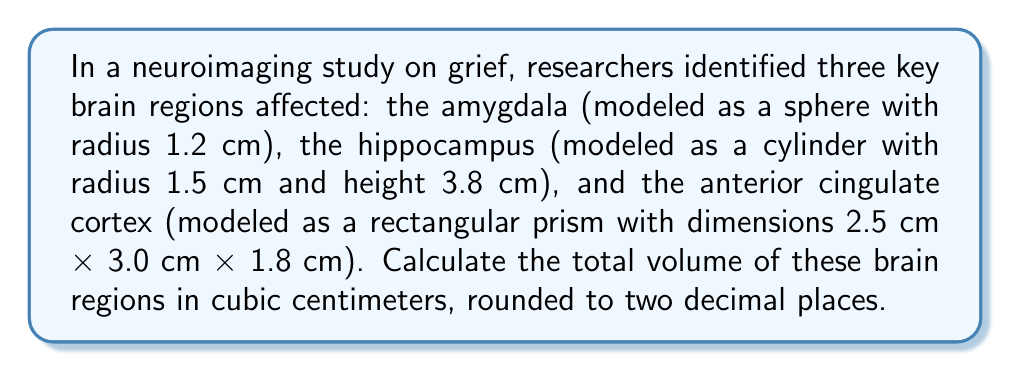Help me with this question. To solve this problem, we need to calculate the volume of each brain region and then sum them up:

1. Amygdala (sphere):
   Volume of a sphere: $V = \frac{4}{3}\pi r^3$
   $V_{amygdala} = \frac{4}{3}\pi (1.2)^3 = \frac{4}{3}\pi (1.728) = 7.2382$ cm³

2. Hippocampus (cylinder):
   Volume of a cylinder: $V = \pi r^2 h$
   $V_{hippocampus} = \pi (1.5)^2 (3.8) = \pi (2.25) (3.8) = 26.7035$ cm³

3. Anterior cingulate cortex (rectangular prism):
   Volume of a rectangular prism: $V = l \times w \times h$
   $V_{ACC} = 2.5 \times 3.0 \times 1.8 = 13.5$ cm³

Total volume:
$V_{total} = V_{amygdala} + V_{hippocampus} + V_{ACC}$
$V_{total} = 7.2382 + 26.7035 + 13.5 = 47.4417$ cm³

Rounding to two decimal places: 47.44 cm³
Answer: 47.44 cm³ 